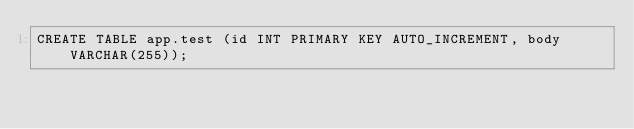<code> <loc_0><loc_0><loc_500><loc_500><_SQL_>CREATE TABLE app.test (id INT PRIMARY KEY AUTO_INCREMENT, body VARCHAR(255));
</code> 